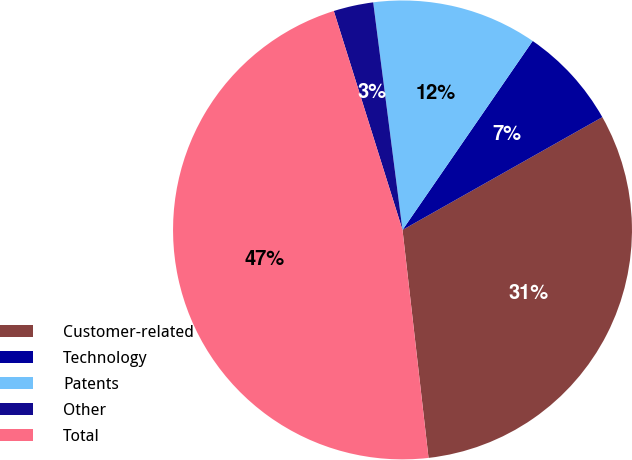Convert chart to OTSL. <chart><loc_0><loc_0><loc_500><loc_500><pie_chart><fcel>Customer-related<fcel>Technology<fcel>Patents<fcel>Other<fcel>Total<nl><fcel>31.37%<fcel>7.22%<fcel>11.64%<fcel>2.8%<fcel>46.97%<nl></chart> 